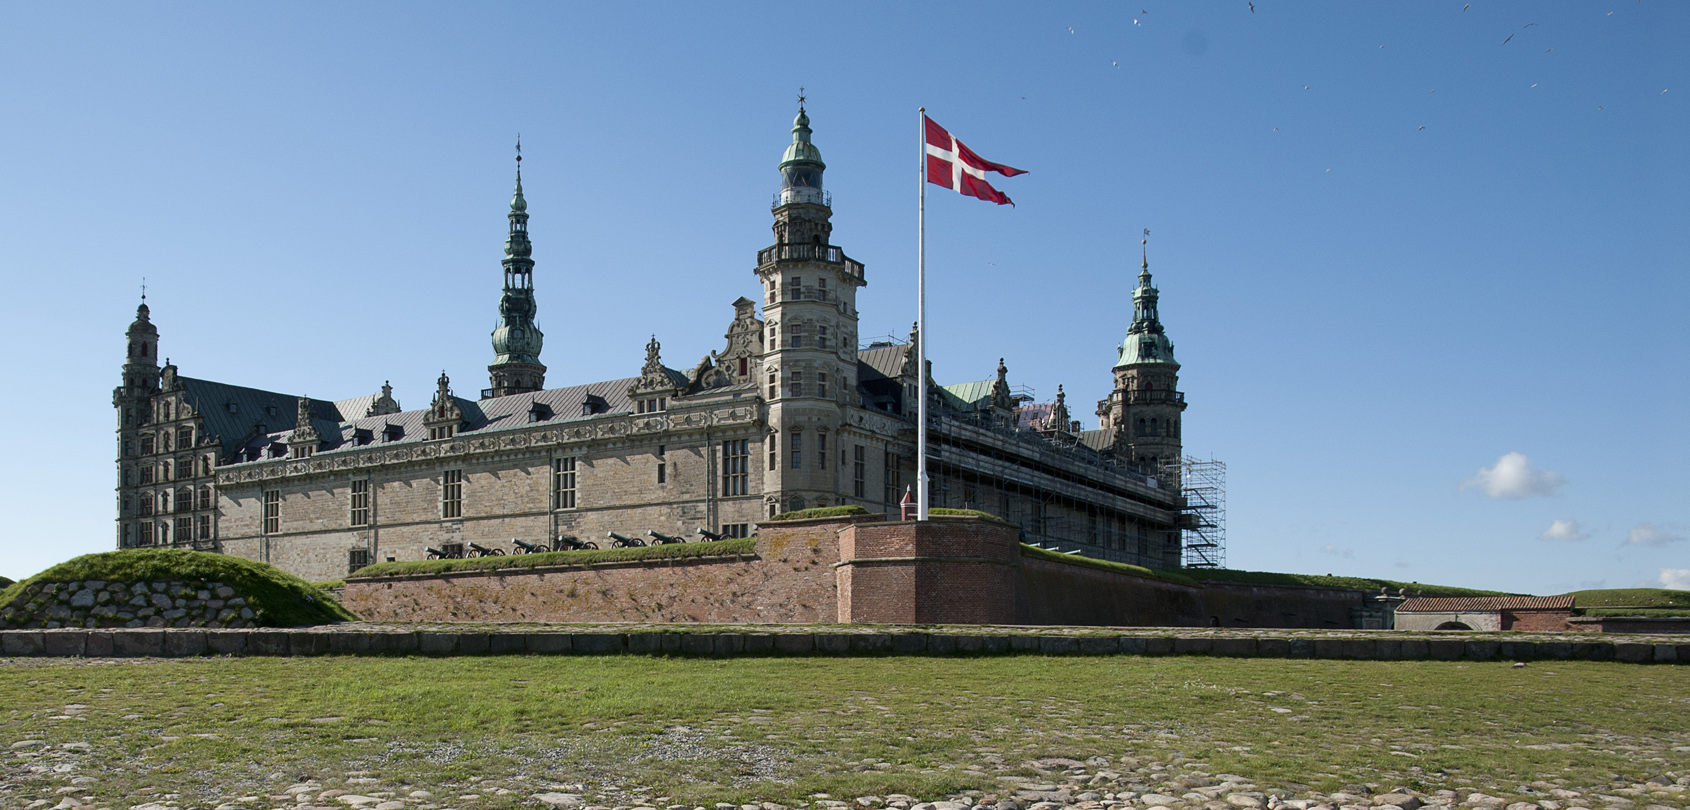Can you elaborate on the elements of the picture provided? The image showcases the impressive Kronborg Castle, a historic landmark from the 16th century located in Helsingør, Denmark. This remarkable structure is built from brick and features a green roof that contrasts beautifully with the clear blue sky above. The castle is adorned with multiple towers and spires, enhancing its majestic appearance as they reach skyward. In the foreground, the Danish flag proudly waves on a flagpole, symbolizing national pride. The castle is encircled by a moat, a common defensive feature in historical fortifications, which underscores its historical significance. A serene grassy area in the foreground adds tranquility to the scene, complementing the castle's grandeur. Notably, scaffolding on one side of the castle indicates ongoing restoration efforts, highlighting the dedication to preserving this important piece of Denmark's architectural heritage. 